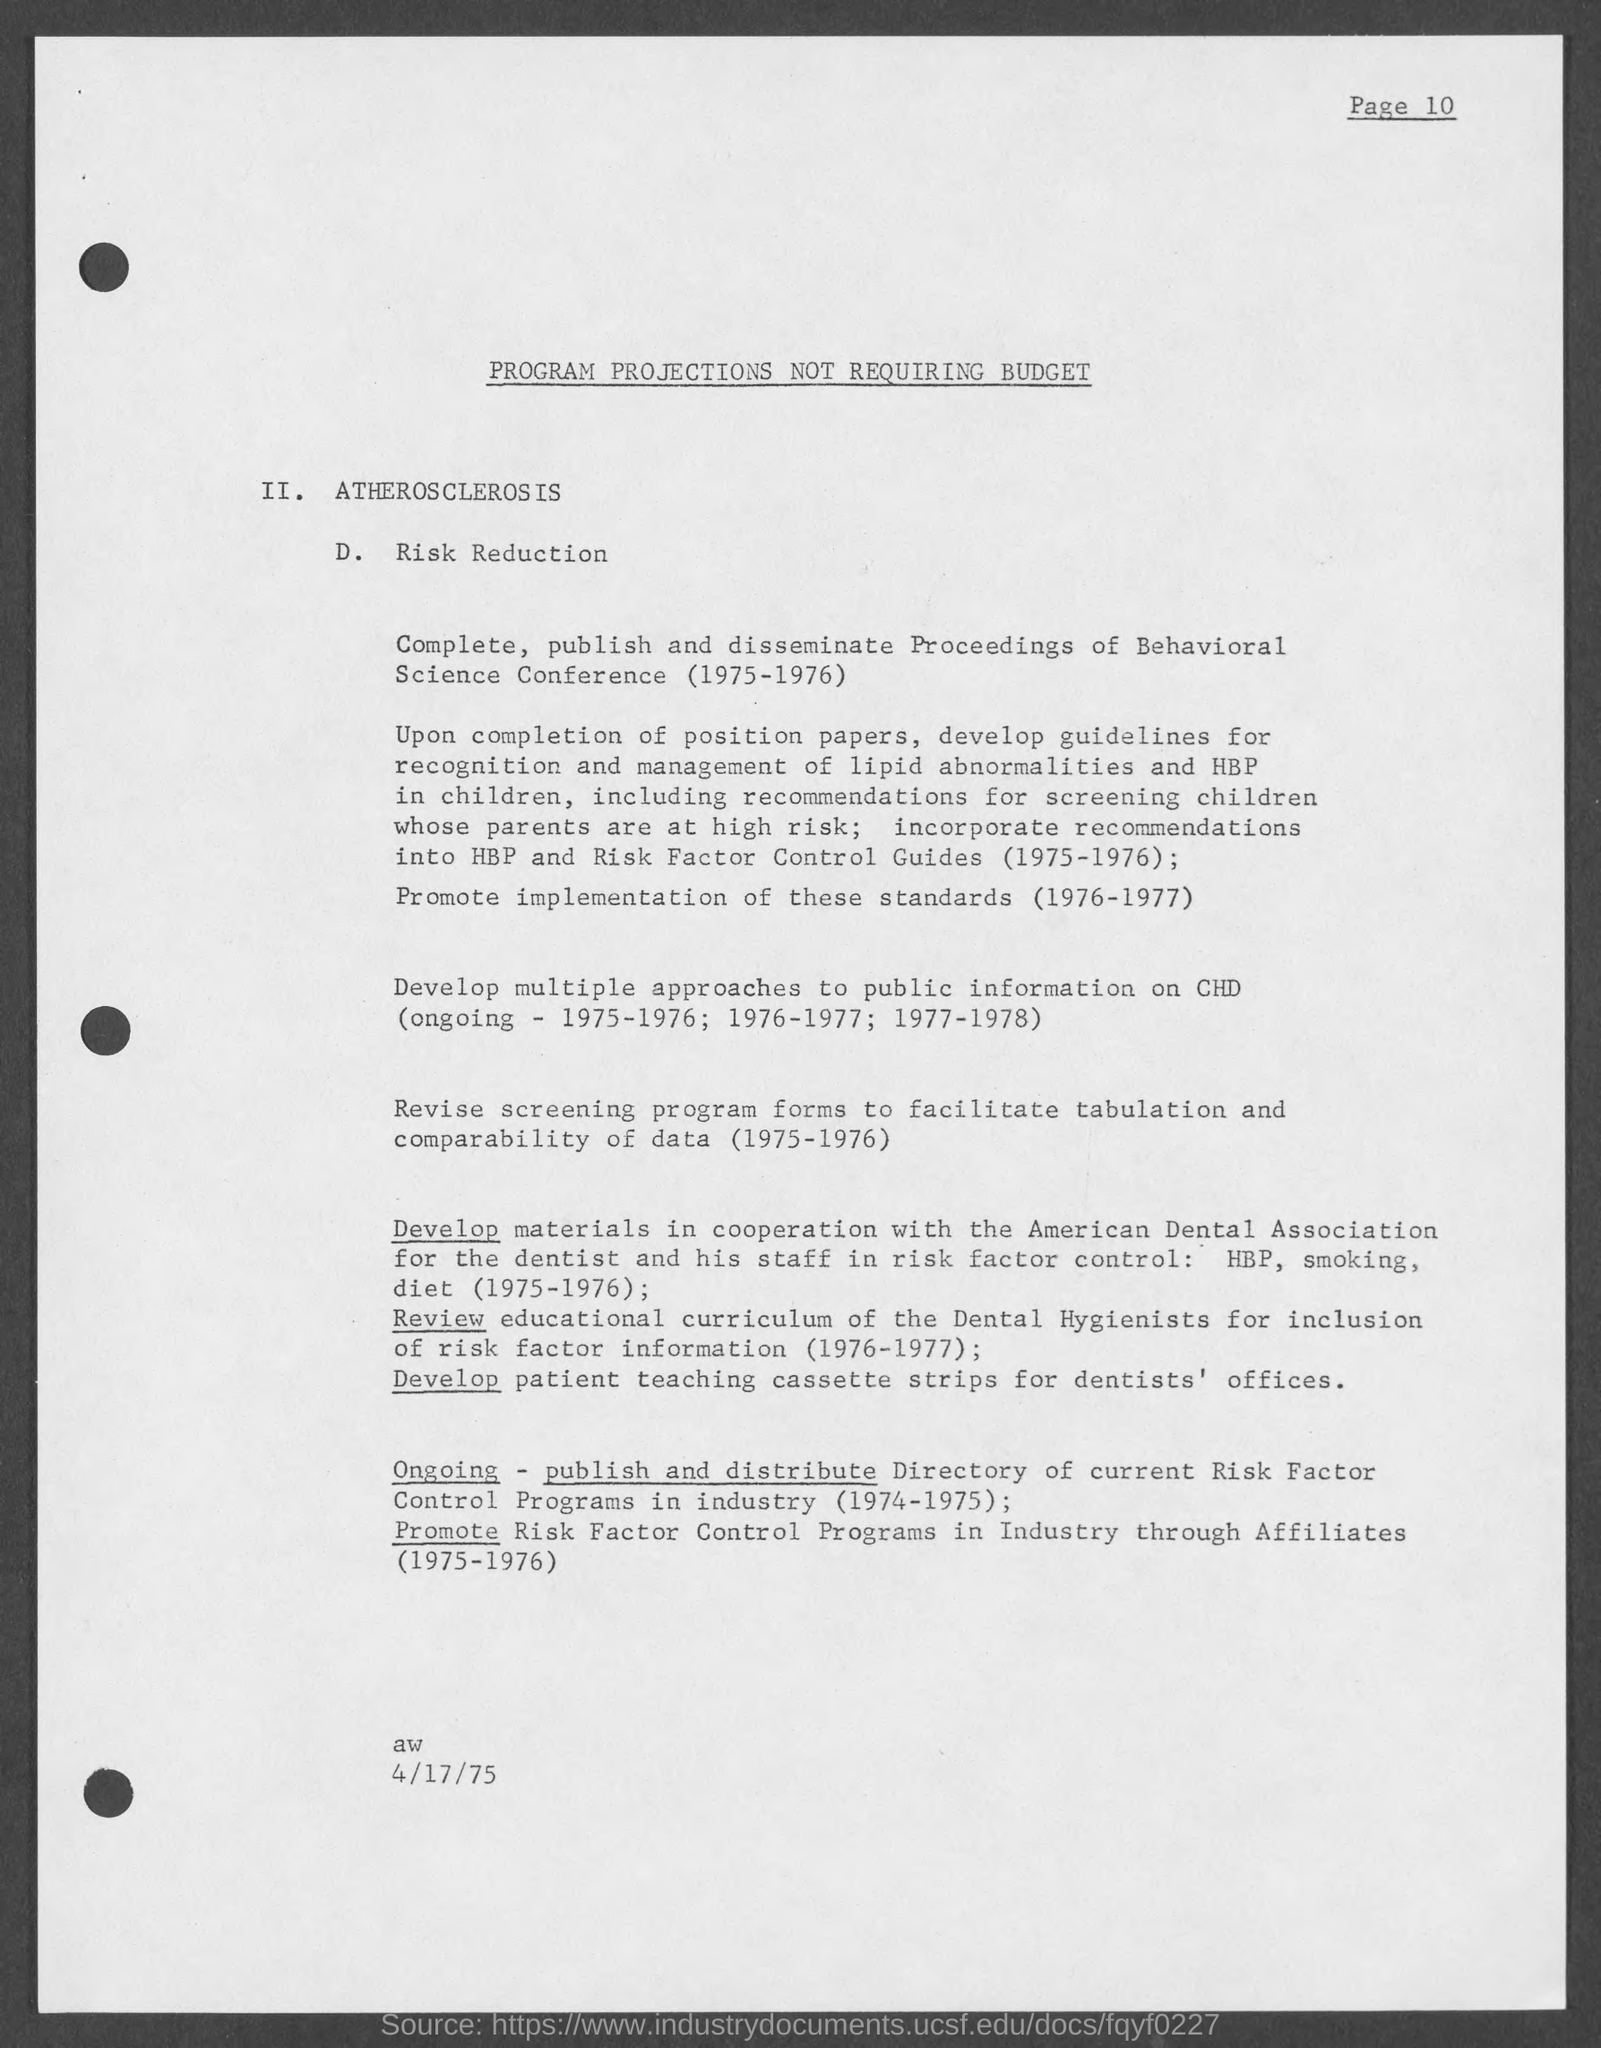List a handful of essential elements in this visual. The main heading of this document is 'PROGRAM PROJECTIONS NOT REQUIRING BUDGET'. The document mentions a date of April 17, 1975. 